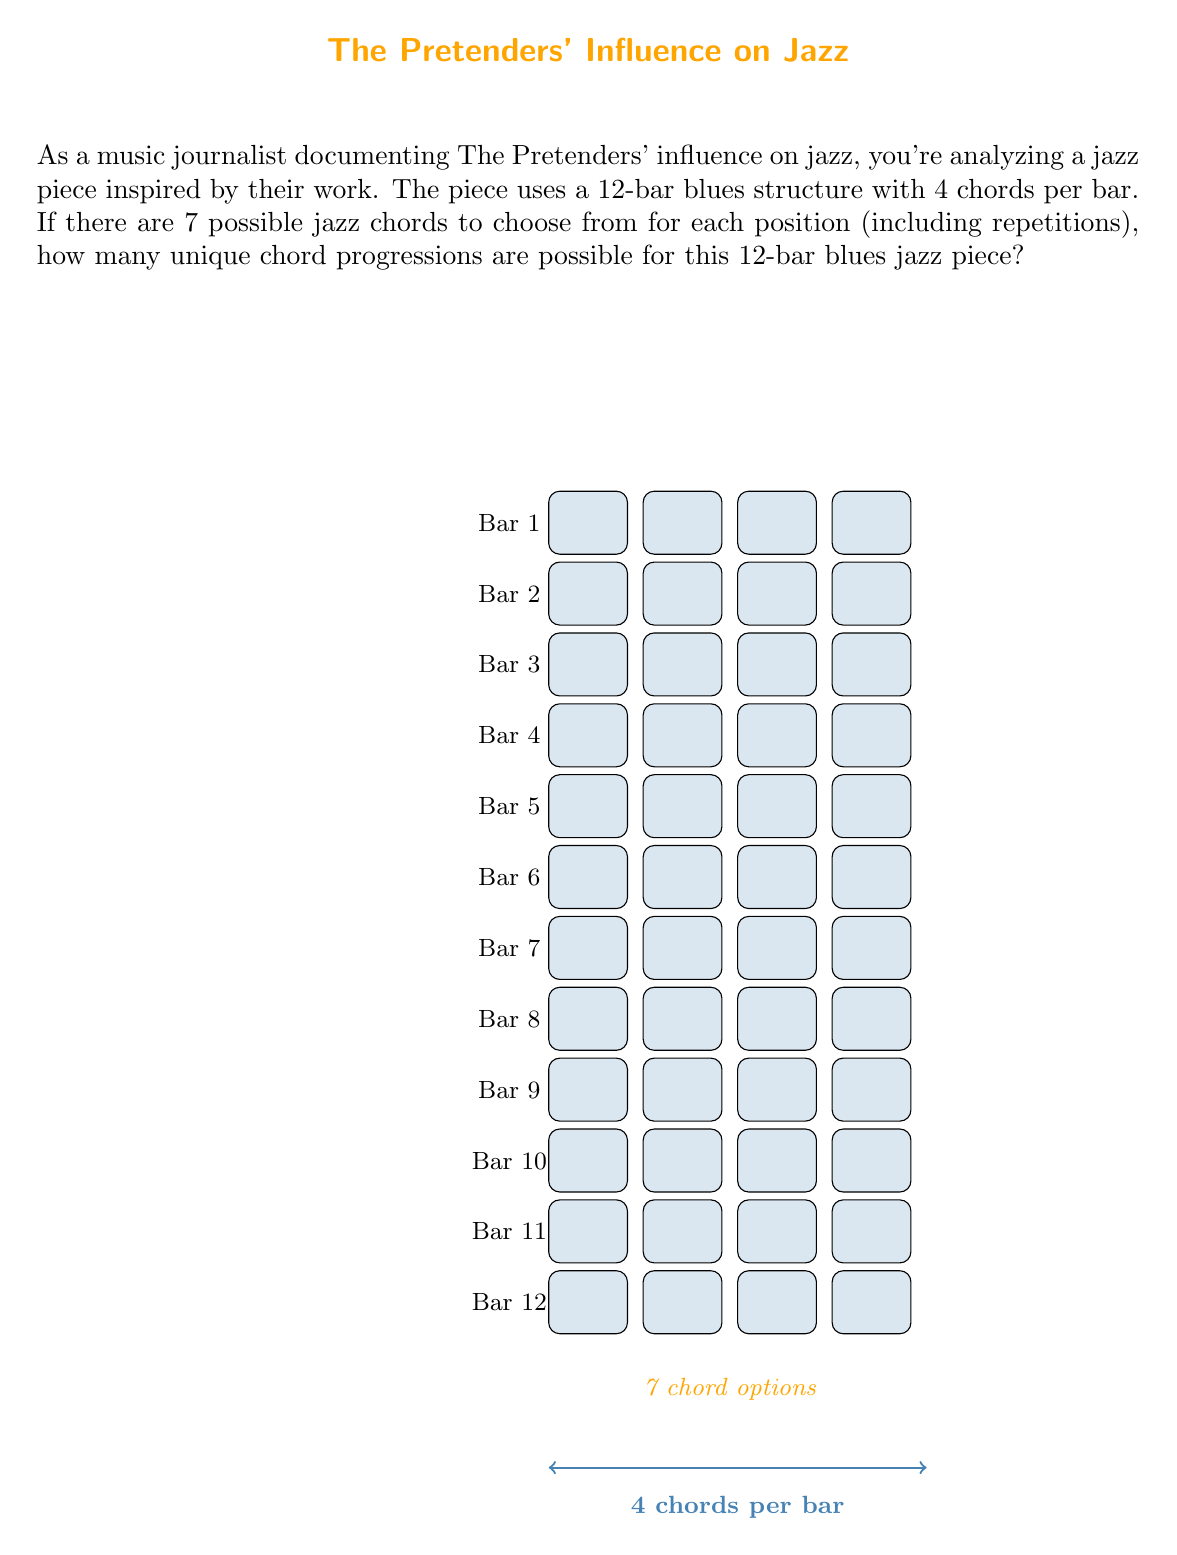Could you help me with this problem? Let's approach this step-by-step:

1) First, we need to understand the structure:
   - There are 12 bars in total
   - Each bar has 4 chord positions
   - So, there are $12 \times 4 = 48$ total chord positions to fill

2) For each of these 48 positions, we have 7 possible chord choices

3) This scenario represents the multiplication principle in combinatorics. When we have a series of independent choices, we multiply the number of options for each choice

4) In this case, we're making 48 independent choices, each with 7 options

5) Therefore, the total number of possible chord progressions is:

   $$7^{48}$$

6) This is an extremely large number. To get a sense of its magnitude:

   $$7^{48} = 7.8848942 \times 10^{40}$$

This immense number of possibilities illustrates the vast creative potential in jazz composition, even within a structured format like the 12-bar blues, reflecting the innovative spirit that The Pretenders brought to their jazz-influenced work.
Answer: $7^{48}$ 